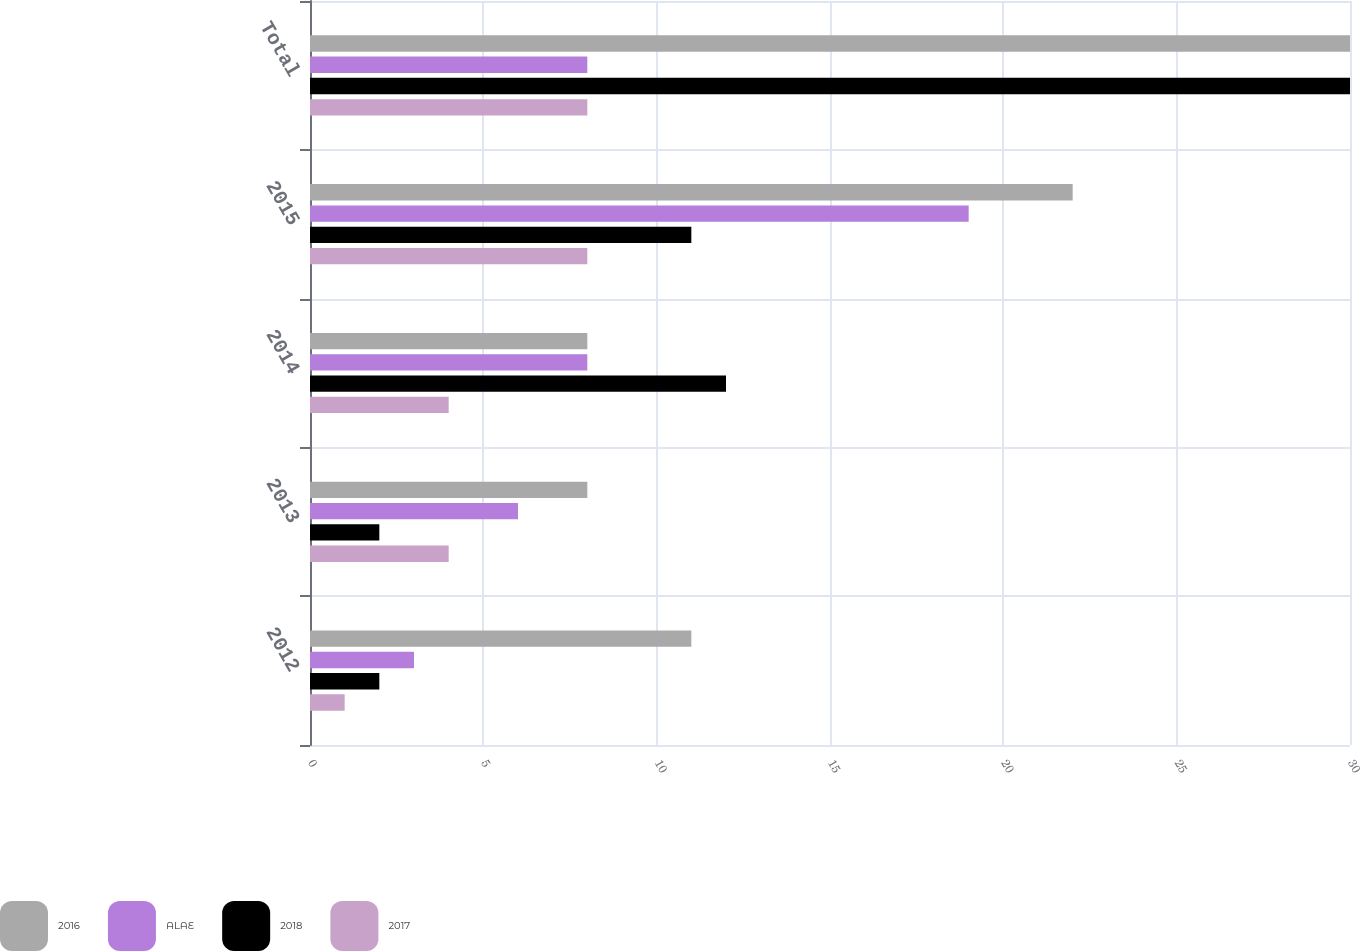Convert chart to OTSL. <chart><loc_0><loc_0><loc_500><loc_500><stacked_bar_chart><ecel><fcel>2012<fcel>2013<fcel>2014<fcel>2015<fcel>Total<nl><fcel>2016<fcel>11<fcel>8<fcel>8<fcel>22<fcel>30<nl><fcel>ALAE<fcel>3<fcel>6<fcel>8<fcel>19<fcel>8<nl><fcel>2018<fcel>2<fcel>2<fcel>12<fcel>11<fcel>30<nl><fcel>2017<fcel>1<fcel>4<fcel>4<fcel>8<fcel>8<nl></chart> 